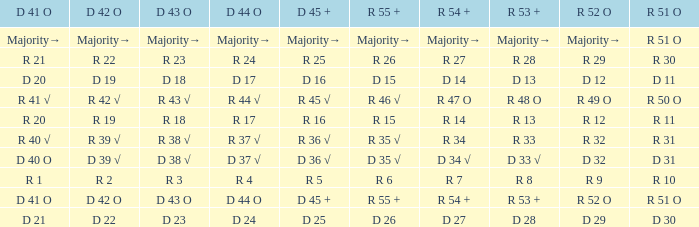What is the value of D 43 O that has a corresponding R 53 + value of r 8? R 3. 